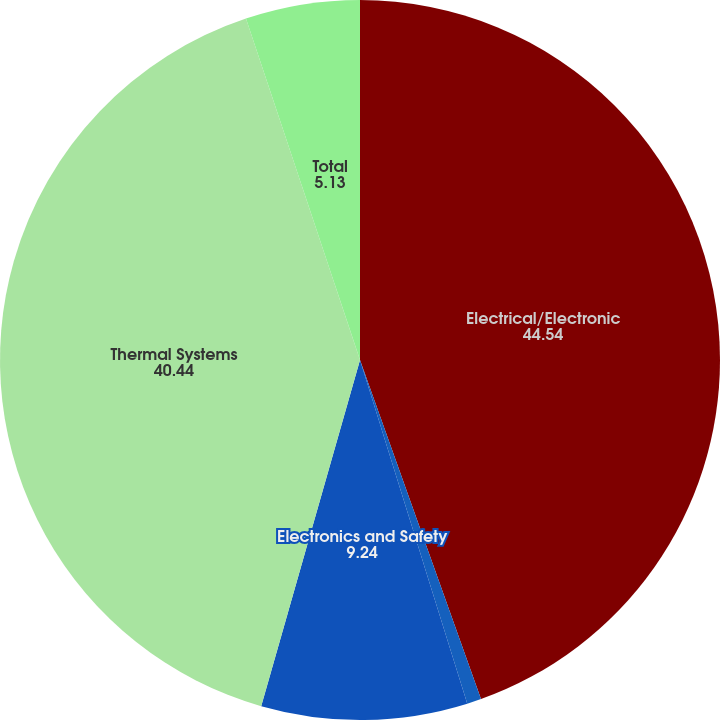Convert chart. <chart><loc_0><loc_0><loc_500><loc_500><pie_chart><fcel>Electrical/Electronic<fcel>Powertrain Systems<fcel>Electronics and Safety<fcel>Thermal Systems<fcel>Total<nl><fcel>44.54%<fcel>0.64%<fcel>9.24%<fcel>40.44%<fcel>5.13%<nl></chart> 